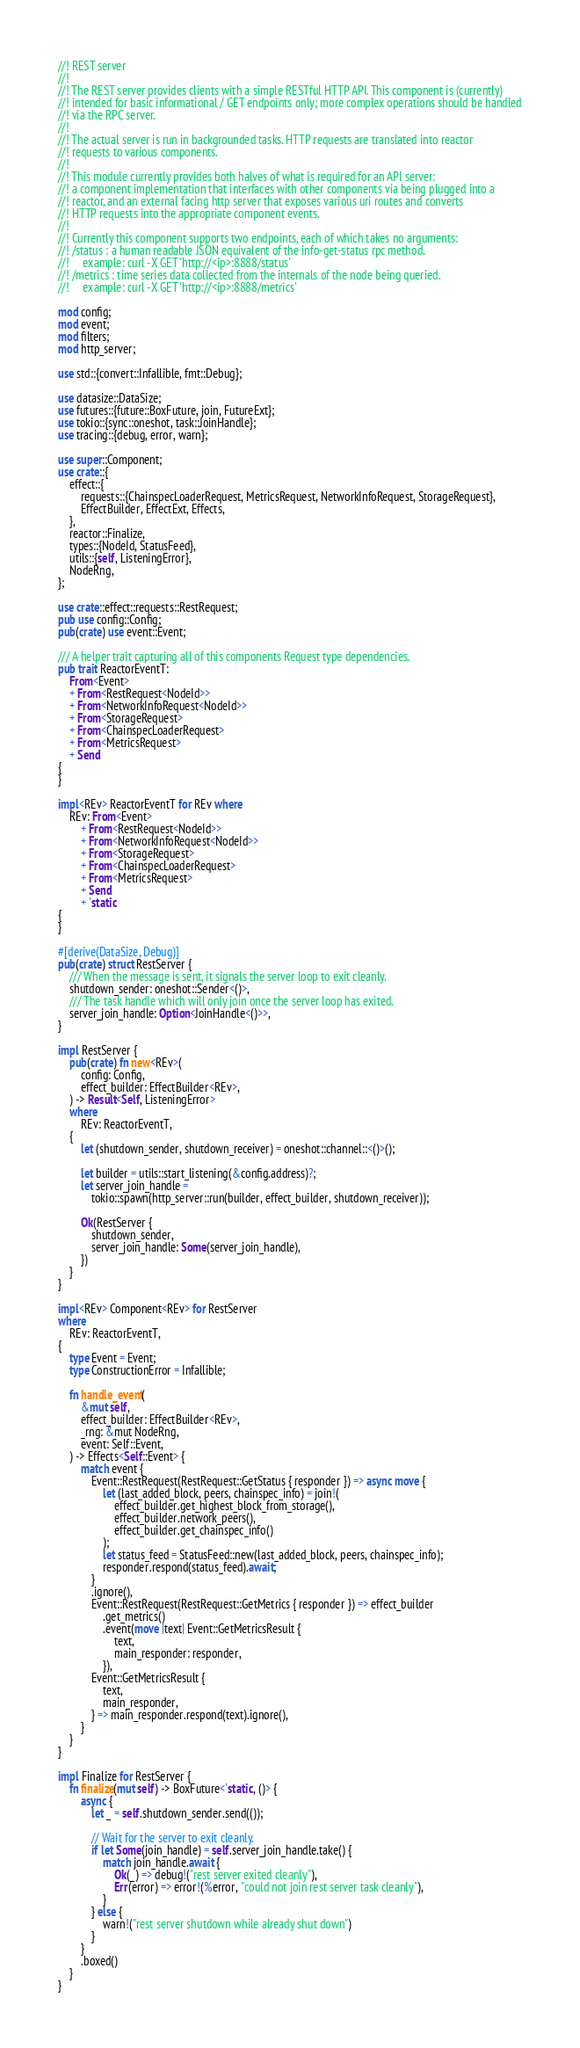<code> <loc_0><loc_0><loc_500><loc_500><_Rust_>//! REST server
//!
//! The REST server provides clients with a simple RESTful HTTP API. This component is (currently)
//! intended for basic informational / GET endpoints only; more complex operations should be handled
//! via the RPC server.
//!
//! The actual server is run in backgrounded tasks. HTTP requests are translated into reactor
//! requests to various components.
//!
//! This module currently provides both halves of what is required for an API server:
//! a component implementation that interfaces with other components via being plugged into a
//! reactor, and an external facing http server that exposes various uri routes and converts
//! HTTP requests into the appropriate component events.
//!
//! Currently this component supports two endpoints, each of which takes no arguments:
//! /status : a human readable JSON equivalent of the info-get-status rpc method.
//!     example: curl -X GET 'http://<ip>:8888/status'
//! /metrics : time series data collected from the internals of the node being queried.
//!     example: curl -X GET 'http://<ip>:8888/metrics'

mod config;
mod event;
mod filters;
mod http_server;

use std::{convert::Infallible, fmt::Debug};

use datasize::DataSize;
use futures::{future::BoxFuture, join, FutureExt};
use tokio::{sync::oneshot, task::JoinHandle};
use tracing::{debug, error, warn};

use super::Component;
use crate::{
    effect::{
        requests::{ChainspecLoaderRequest, MetricsRequest, NetworkInfoRequest, StorageRequest},
        EffectBuilder, EffectExt, Effects,
    },
    reactor::Finalize,
    types::{NodeId, StatusFeed},
    utils::{self, ListeningError},
    NodeRng,
};

use crate::effect::requests::RestRequest;
pub use config::Config;
pub(crate) use event::Event;

/// A helper trait capturing all of this components Request type dependencies.
pub trait ReactorEventT:
    From<Event>
    + From<RestRequest<NodeId>>
    + From<NetworkInfoRequest<NodeId>>
    + From<StorageRequest>
    + From<ChainspecLoaderRequest>
    + From<MetricsRequest>
    + Send
{
}

impl<REv> ReactorEventT for REv where
    REv: From<Event>
        + From<RestRequest<NodeId>>
        + From<NetworkInfoRequest<NodeId>>
        + From<StorageRequest>
        + From<ChainspecLoaderRequest>
        + From<MetricsRequest>
        + Send
        + 'static
{
}

#[derive(DataSize, Debug)]
pub(crate) struct RestServer {
    /// When the message is sent, it signals the server loop to exit cleanly.
    shutdown_sender: oneshot::Sender<()>,
    /// The task handle which will only join once the server loop has exited.
    server_join_handle: Option<JoinHandle<()>>,
}

impl RestServer {
    pub(crate) fn new<REv>(
        config: Config,
        effect_builder: EffectBuilder<REv>,
    ) -> Result<Self, ListeningError>
    where
        REv: ReactorEventT,
    {
        let (shutdown_sender, shutdown_receiver) = oneshot::channel::<()>();

        let builder = utils::start_listening(&config.address)?;
        let server_join_handle =
            tokio::spawn(http_server::run(builder, effect_builder, shutdown_receiver));

        Ok(RestServer {
            shutdown_sender,
            server_join_handle: Some(server_join_handle),
        })
    }
}

impl<REv> Component<REv> for RestServer
where
    REv: ReactorEventT,
{
    type Event = Event;
    type ConstructionError = Infallible;

    fn handle_event(
        &mut self,
        effect_builder: EffectBuilder<REv>,
        _rng: &mut NodeRng,
        event: Self::Event,
    ) -> Effects<Self::Event> {
        match event {
            Event::RestRequest(RestRequest::GetStatus { responder }) => async move {
                let (last_added_block, peers, chainspec_info) = join!(
                    effect_builder.get_highest_block_from_storage(),
                    effect_builder.network_peers(),
                    effect_builder.get_chainspec_info()
                );
                let status_feed = StatusFeed::new(last_added_block, peers, chainspec_info);
                responder.respond(status_feed).await;
            }
            .ignore(),
            Event::RestRequest(RestRequest::GetMetrics { responder }) => effect_builder
                .get_metrics()
                .event(move |text| Event::GetMetricsResult {
                    text,
                    main_responder: responder,
                }),
            Event::GetMetricsResult {
                text,
                main_responder,
            } => main_responder.respond(text).ignore(),
        }
    }
}

impl Finalize for RestServer {
    fn finalize(mut self) -> BoxFuture<'static, ()> {
        async {
            let _ = self.shutdown_sender.send(());

            // Wait for the server to exit cleanly.
            if let Some(join_handle) = self.server_join_handle.take() {
                match join_handle.await {
                    Ok(_) => debug!("rest server exited cleanly"),
                    Err(error) => error!(%error, "could not join rest server task cleanly"),
                }
            } else {
                warn!("rest server shutdown while already shut down")
            }
        }
        .boxed()
    }
}
</code> 